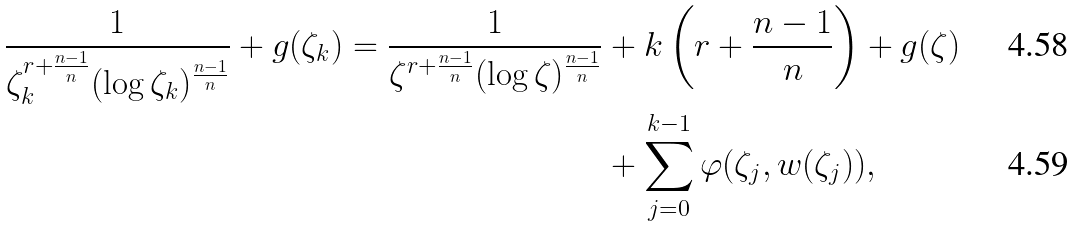<formula> <loc_0><loc_0><loc_500><loc_500>\frac { 1 } { \zeta _ { k } ^ { r + \frac { n - 1 } { n } } ( \log \zeta _ { k } ) ^ { \frac { n - 1 } { n } } } + g ( \zeta _ { k } ) = \frac { 1 } { \zeta ^ { r + \frac { n - 1 } { n } } ( \log \zeta ) ^ { \frac { n - 1 } { n } } } & + k \left ( r + \frac { n - 1 } { n } \right ) + g ( \zeta ) \\ & + \sum _ { j = 0 } ^ { k - 1 } \varphi ( \zeta _ { j } , w ( \zeta _ { j } ) ) ,</formula> 